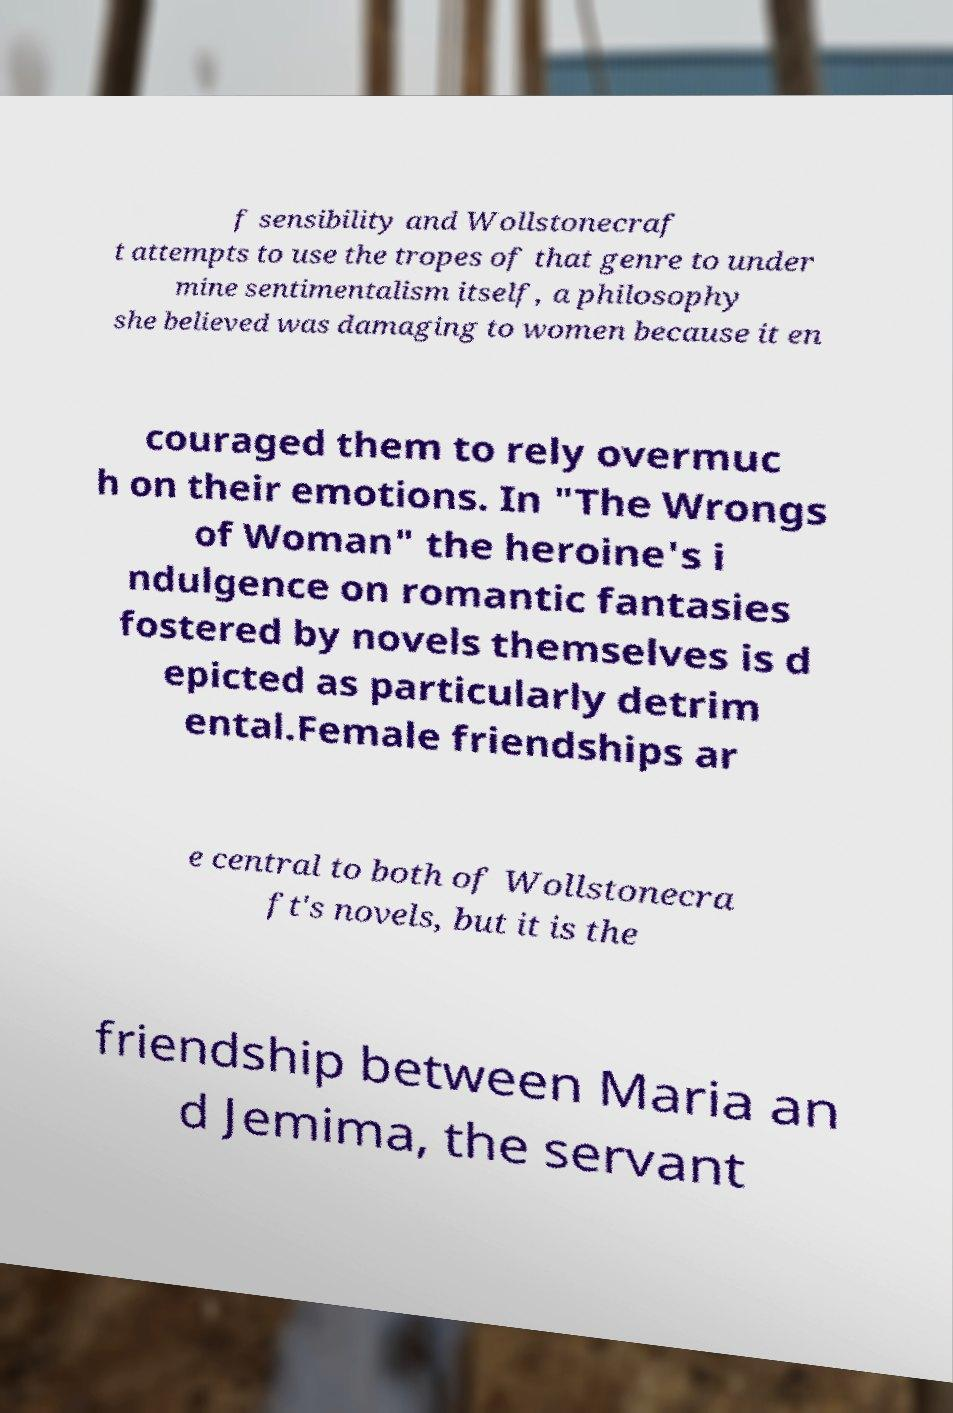Could you assist in decoding the text presented in this image and type it out clearly? f sensibility and Wollstonecraf t attempts to use the tropes of that genre to under mine sentimentalism itself, a philosophy she believed was damaging to women because it en couraged them to rely overmuc h on their emotions. In "The Wrongs of Woman" the heroine's i ndulgence on romantic fantasies fostered by novels themselves is d epicted as particularly detrim ental.Female friendships ar e central to both of Wollstonecra ft's novels, but it is the friendship between Maria an d Jemima, the servant 